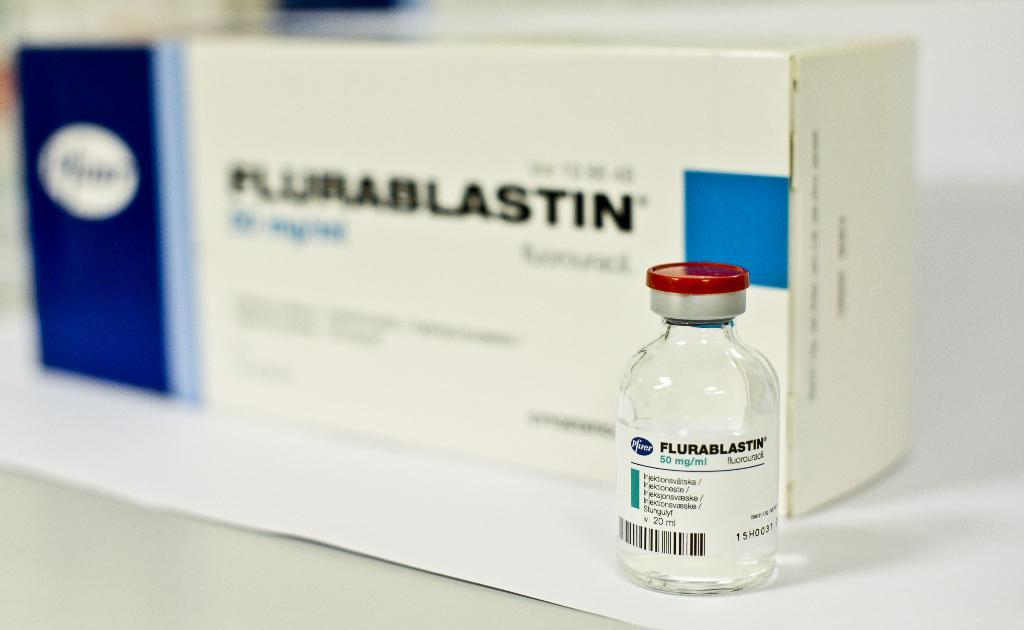<image>
Give a short and clear explanation of the subsequent image. a small bottle of flurablastin in front of a box of flurablastin 